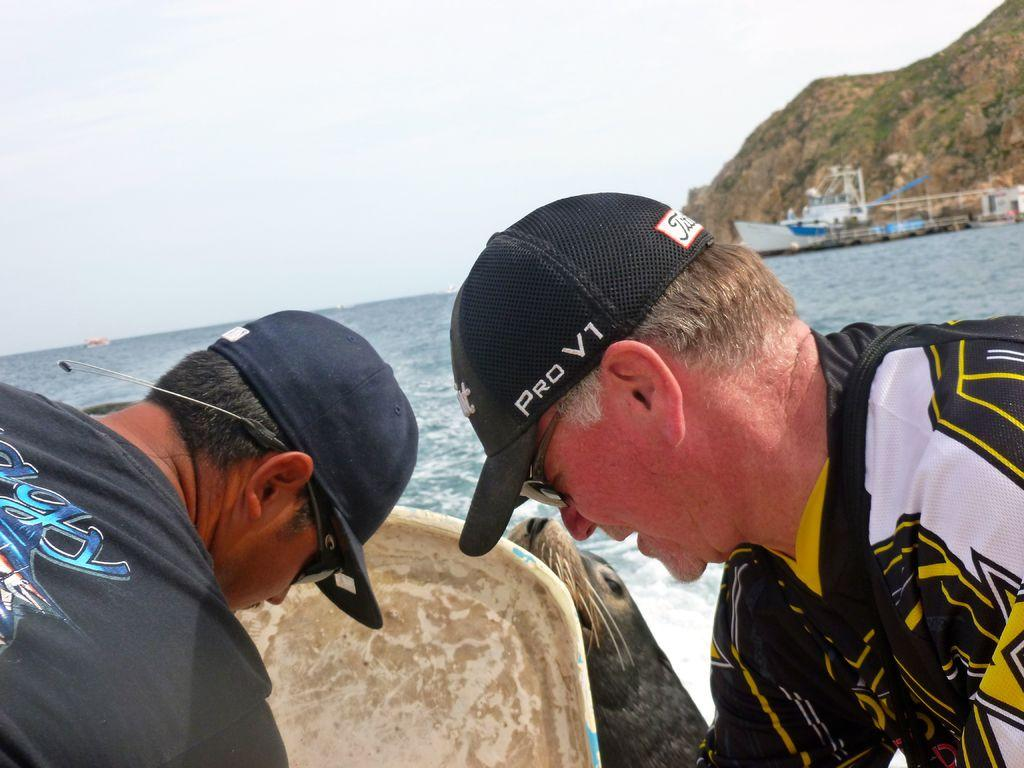How many men are in the image? There are two men in the image. What are the men wearing on their heads? The men are wearing caps. What else are the men wearing? The men are wearing goggles. What else can be seen in the image besides the men? There is an animal, boats on water, mountains, and the sky visible in the background of the image. What type of alley can be seen in the image? There is no alley present in the image; it features two men, an animal, boats on water, mountains, and the sky. 